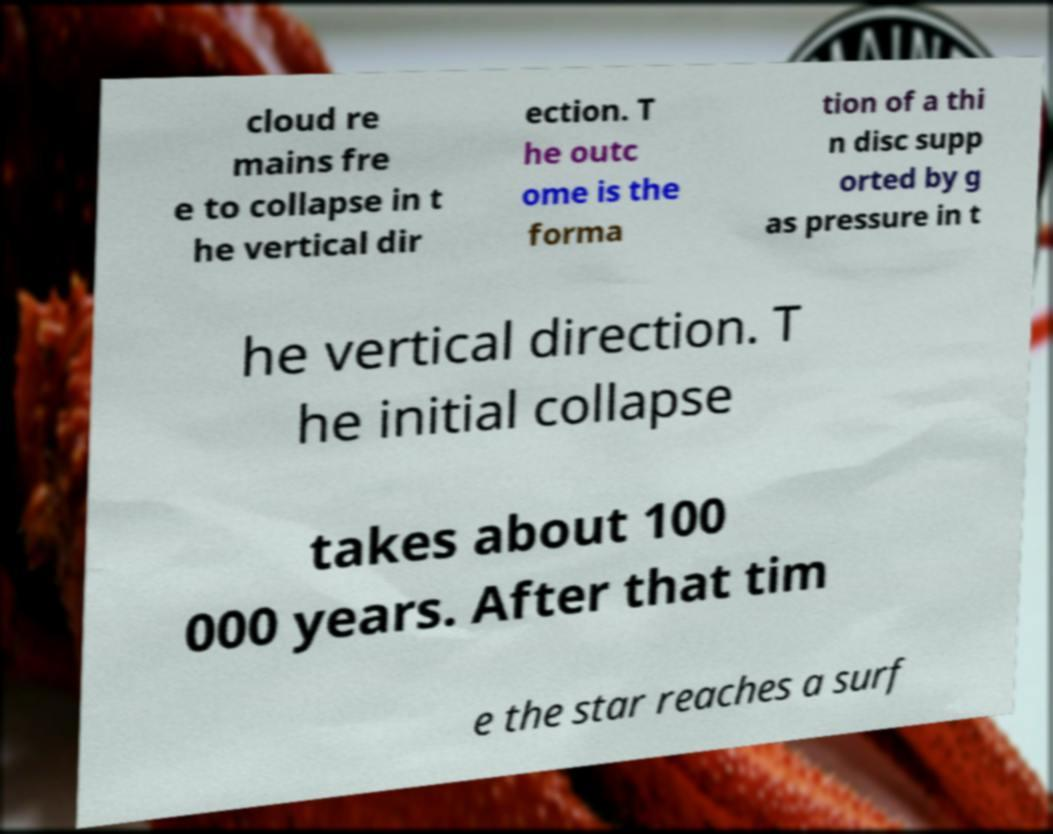There's text embedded in this image that I need extracted. Can you transcribe it verbatim? cloud re mains fre e to collapse in t he vertical dir ection. T he outc ome is the forma tion of a thi n disc supp orted by g as pressure in t he vertical direction. T he initial collapse takes about 100 000 years. After that tim e the star reaches a surf 